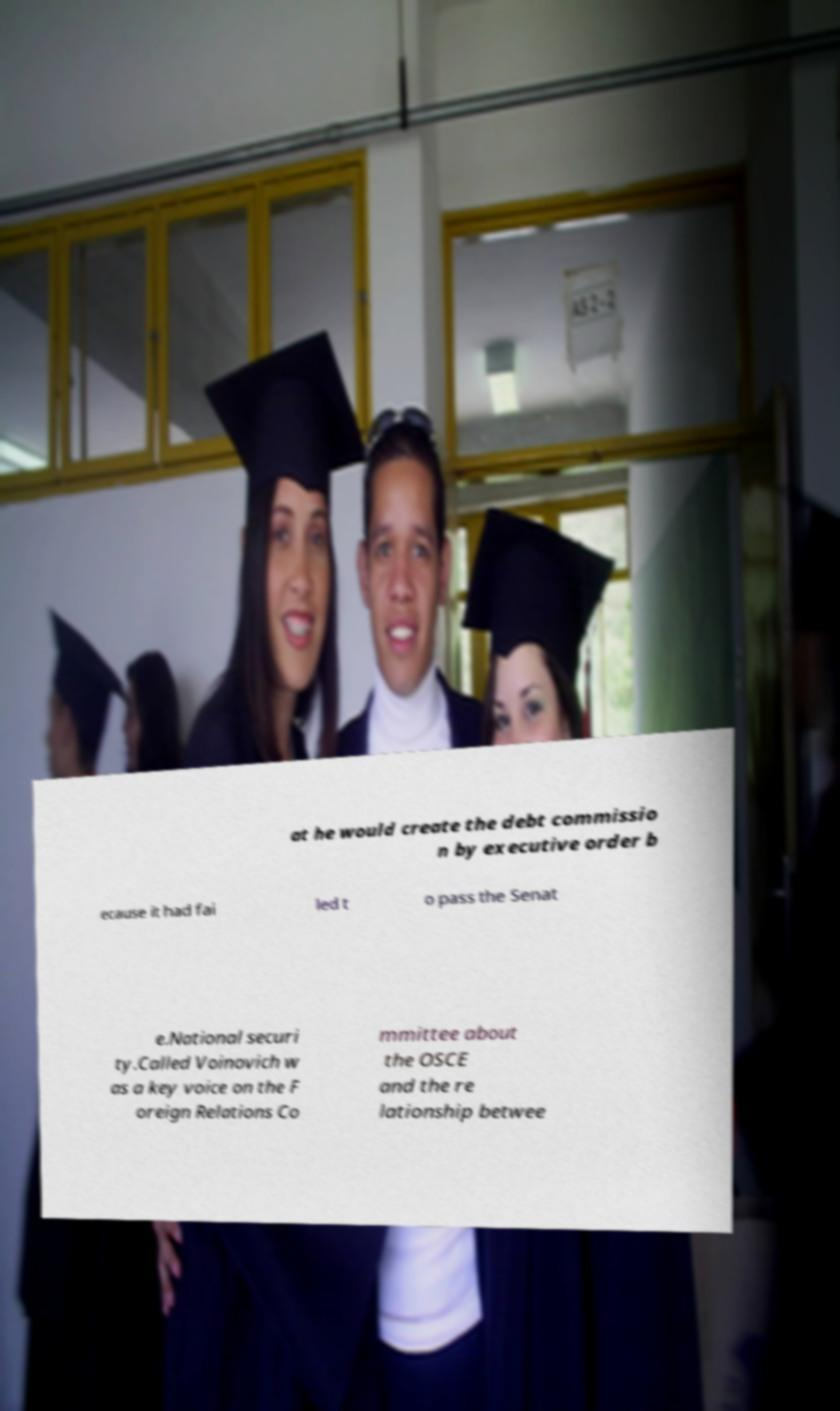Please read and relay the text visible in this image. What does it say? at he would create the debt commissio n by executive order b ecause it had fai led t o pass the Senat e.National securi ty.Called Voinovich w as a key voice on the F oreign Relations Co mmittee about the OSCE and the re lationship betwee 